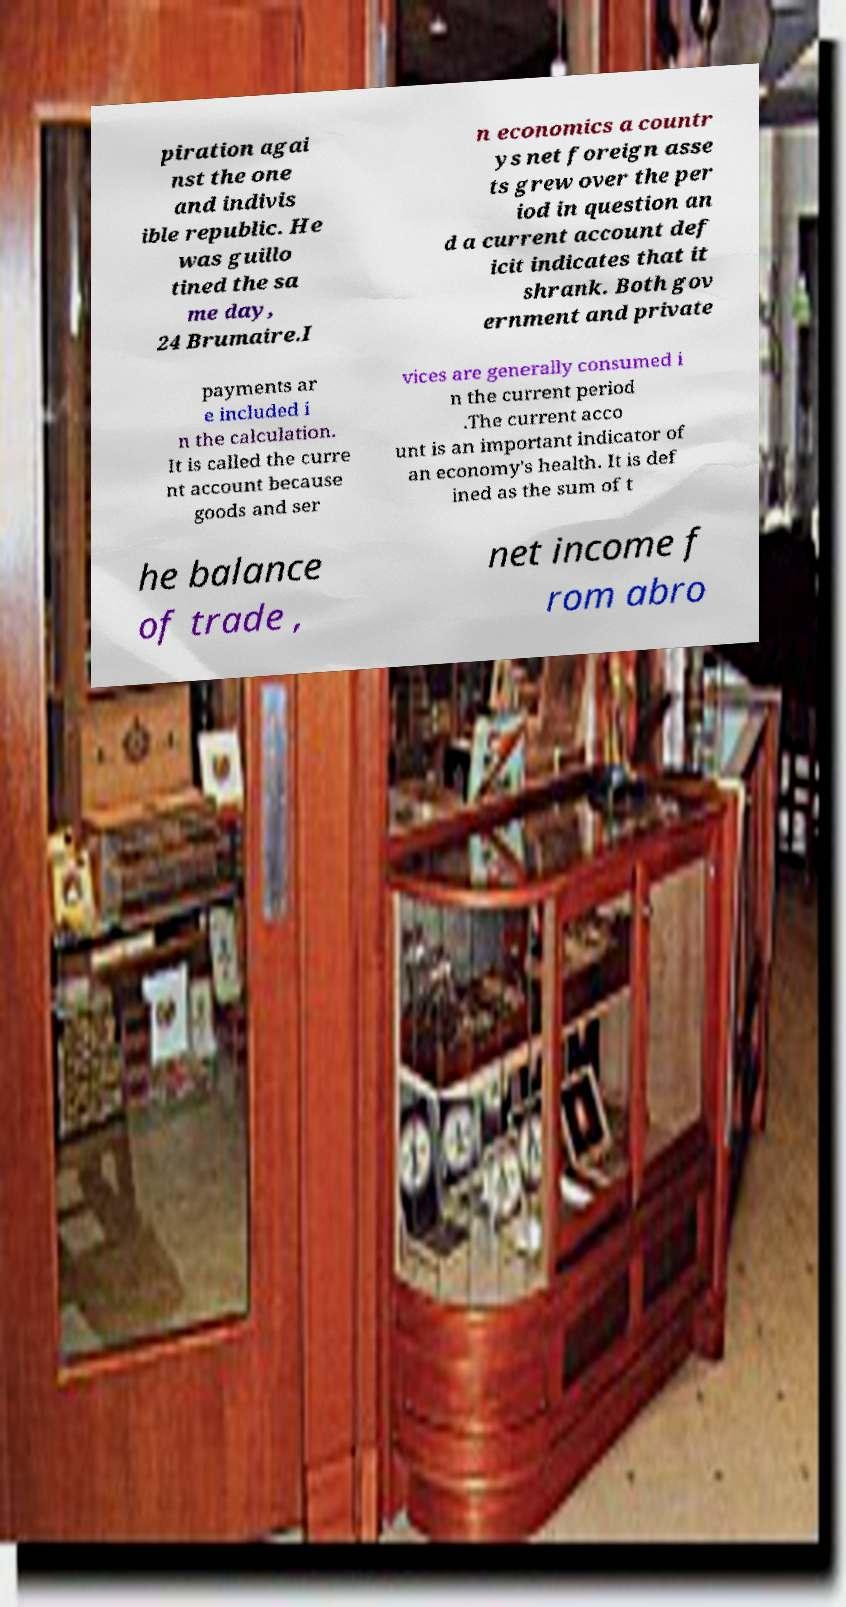Can you accurately transcribe the text from the provided image for me? piration agai nst the one and indivis ible republic. He was guillo tined the sa me day, 24 Brumaire.I n economics a countr ys net foreign asse ts grew over the per iod in question an d a current account def icit indicates that it shrank. Both gov ernment and private payments ar e included i n the calculation. It is called the curre nt account because goods and ser vices are generally consumed i n the current period .The current acco unt is an important indicator of an economy's health. It is def ined as the sum of t he balance of trade , net income f rom abro 